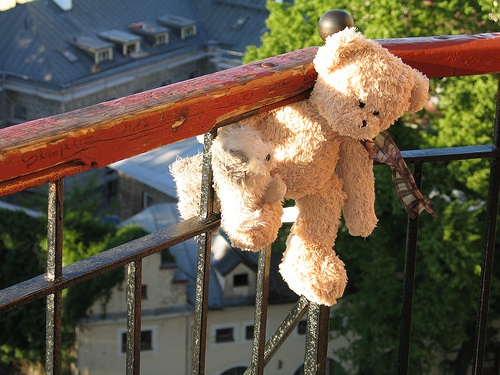Describe the objects in this image and their specific colors. I can see teddy bear in ivory, salmon, tan, and brown tones and teddy bear in ivory, tan, and darkgray tones in this image. 